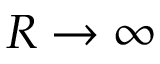Convert formula to latex. <formula><loc_0><loc_0><loc_500><loc_500>R \rightarrow \infty</formula> 